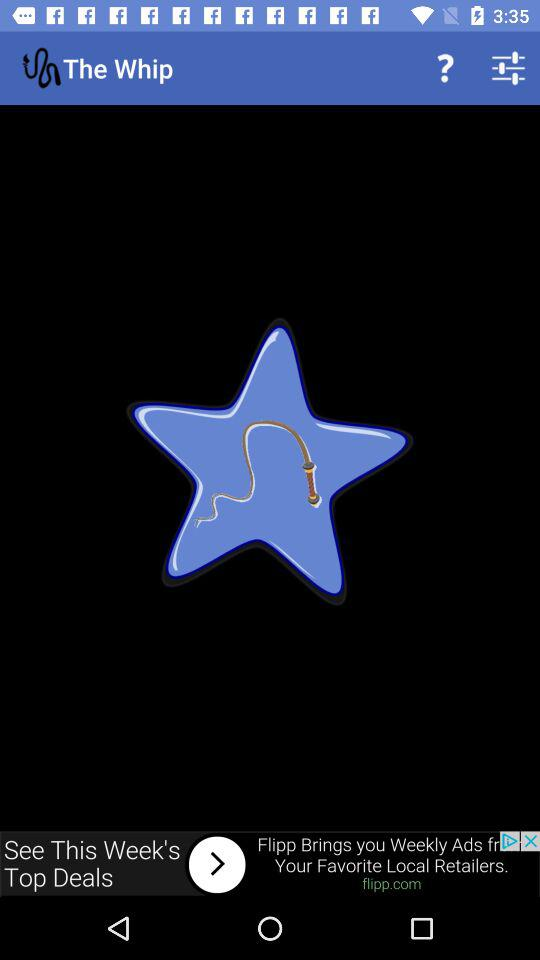What is the name of the application? The application name is "The Whip". 